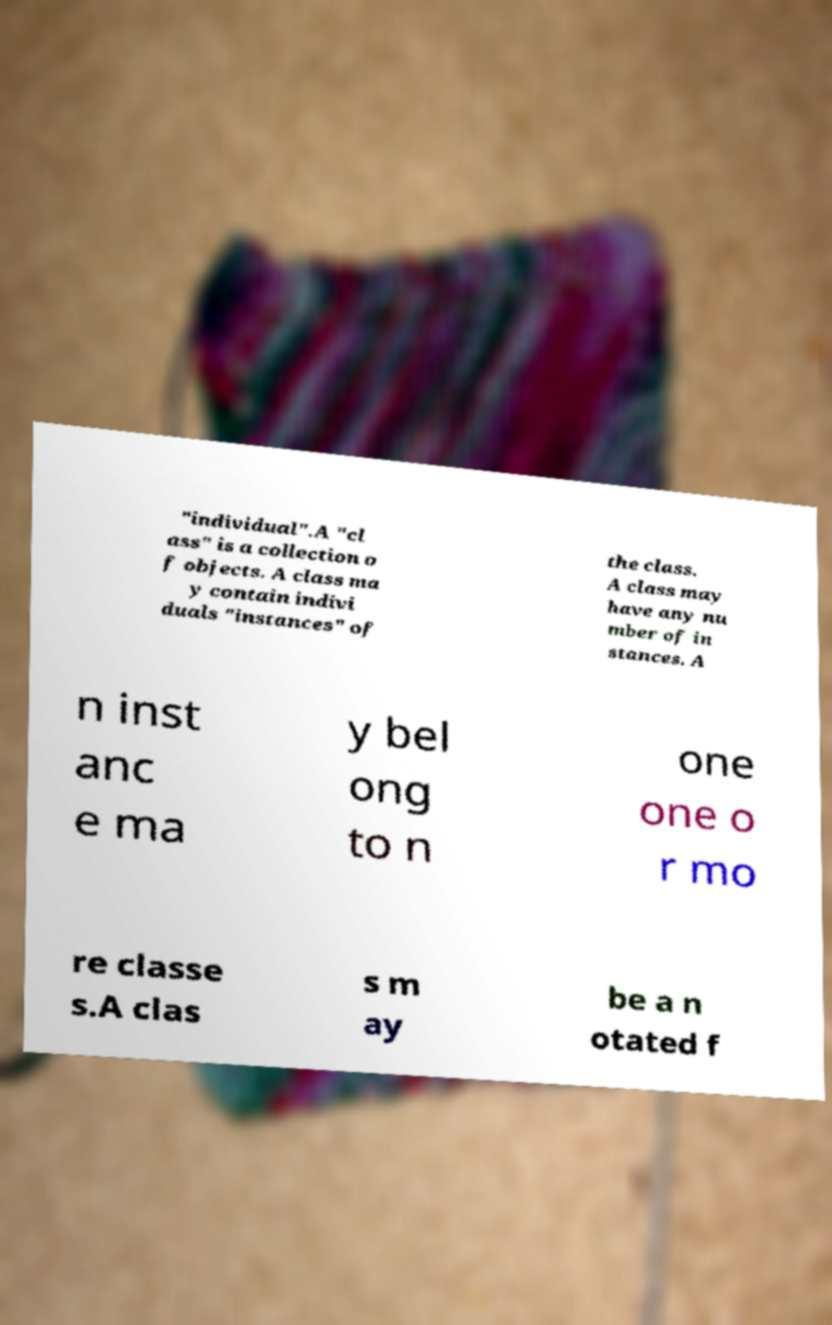There's text embedded in this image that I need extracted. Can you transcribe it verbatim? "individual".A "cl ass" is a collection o f objects. A class ma y contain indivi duals "instances" of the class. A class may have any nu mber of in stances. A n inst anc e ma y bel ong to n one one o r mo re classe s.A clas s m ay be a n otated f 